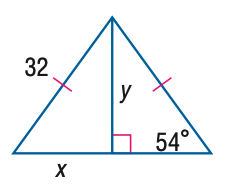Answer the mathemtical geometry problem and directly provide the correct option letter.
Question: Find y. Round to the nearest tenth.
Choices: A: 18.8 B: 23.2 C: 25.9 D: 44.0 C 